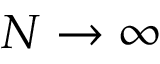Convert formula to latex. <formula><loc_0><loc_0><loc_500><loc_500>N \to \infty</formula> 